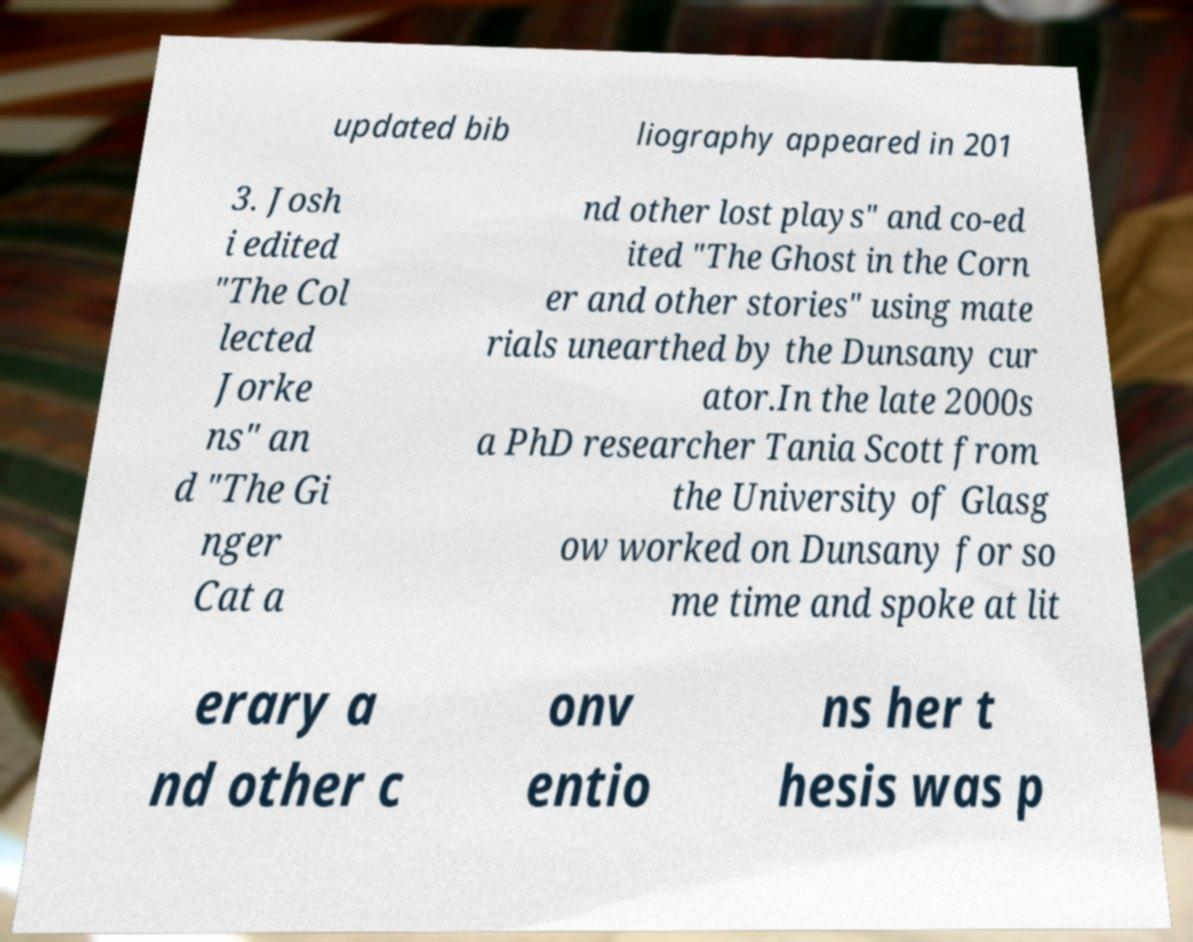There's text embedded in this image that I need extracted. Can you transcribe it verbatim? updated bib liography appeared in 201 3. Josh i edited "The Col lected Jorke ns" an d "The Gi nger Cat a nd other lost plays" and co-ed ited "The Ghost in the Corn er and other stories" using mate rials unearthed by the Dunsany cur ator.In the late 2000s a PhD researcher Tania Scott from the University of Glasg ow worked on Dunsany for so me time and spoke at lit erary a nd other c onv entio ns her t hesis was p 